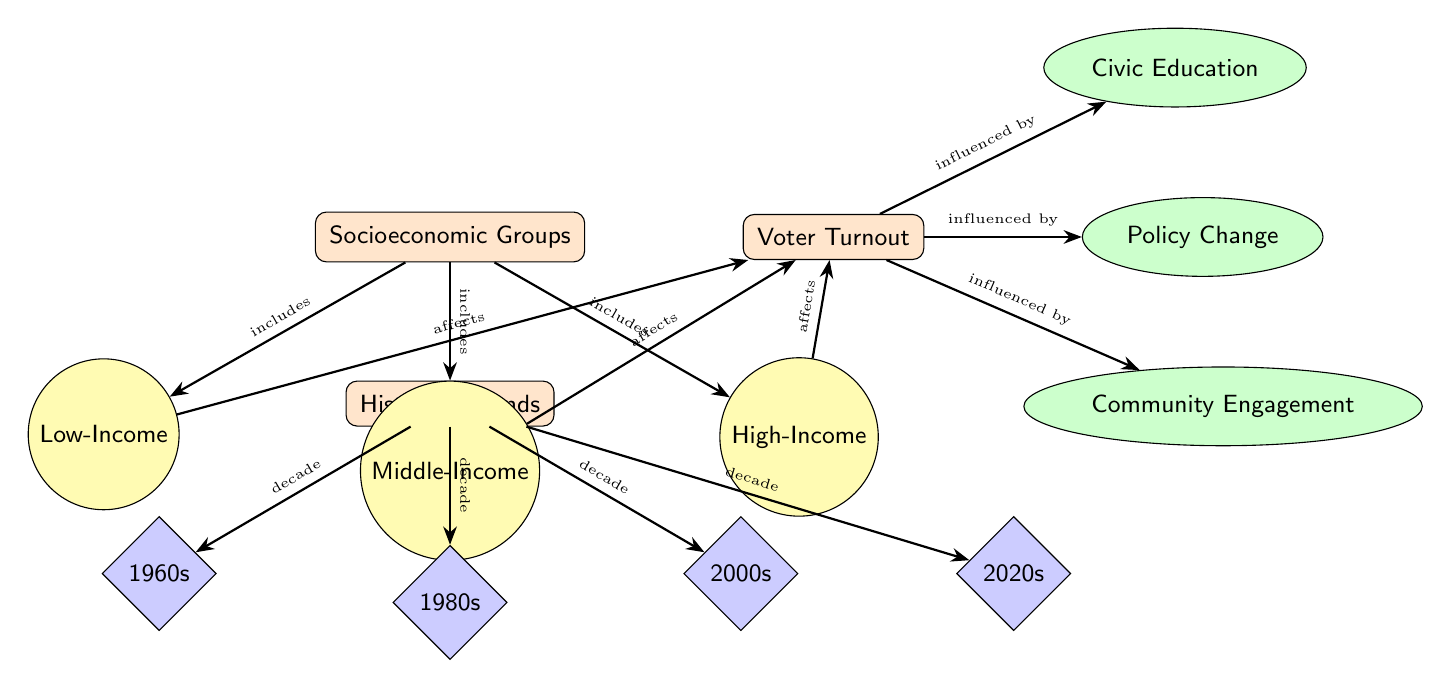What are the socioeconomic groups represented in the diagram? The diagram lists three socioeconomic groups: Low-Income, Middle-Income, and High-Income. These groups are clearly identified as subnodes under the main node "Socioeconomic Groups."
Answer: Low-Income, Middle-Income, High-Income How many decades are represented in the historical trends section? There are four decades represented: 1960s, 1980s, 2000s, and 2020s. This can be counted by observing the nodes labeled as decades under the "Historical Trends" section.
Answer: Four Which socioeconomic group affects voter turnout the most? The diagram does not specify which group affects it the most, as all three groups (Low-Income, Middle-Income, High-Income) are connected to the Voter Turnout node with the same arrow type labeled "affects."
Answer: Not specified What influences voter turnout, as per the diagram? Voter turnout is influenced by Civic Education, Policy Change, and Community Engagement, indicated by arrows leading from the Voter Turnout node to these factors.
Answer: Civic Education, Policy Change, Community Engagement What decade is positioned directly below the historical trends node? The node directly below the "Historical Trends" node is labeled "1960s." This can be determined by the vertical arrangement of nodes connected to the historical trends section.
Answer: 1960s Which socioeconomic group includes the highest income category? The socioeconomic group representing the highest income category is High-Income, as indicated by the label on that specific subgroup node under "Socioeconomic Groups."
Answer: High-Income How many factors influence voter turnout according to this diagram? There are three factors that influence voter turnout: Civic Education, Policy Change, and Community Engagement. This is evident from the three nodes connected to the Voter Turnout node.
Answer: Three What type of diagram is this, based on its characteristics? This is a Social Science Diagram, designed to illustrate relationships and flows between socioeconomic groups, historical trends, voter turnout, and influencing factors. This classification is based on its content and layout.
Answer: Social Science Diagram 